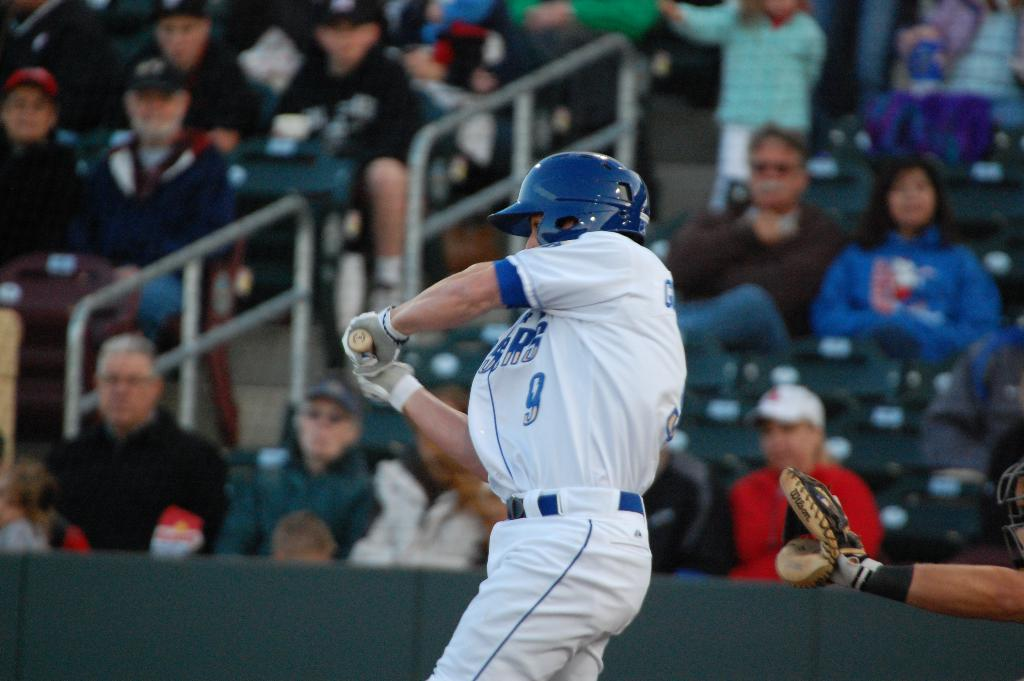<image>
Create a compact narrative representing the image presented. A baseball player wearing number 9 swings at the ball. 